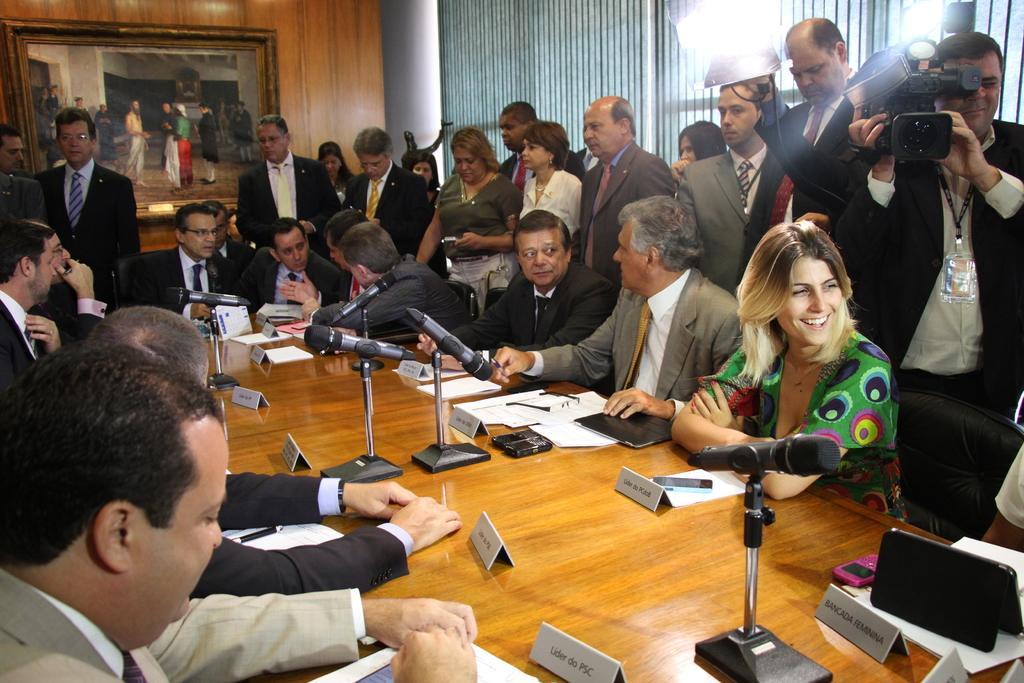Can you describe this image briefly? In this image we can see there are a group of people sitting and in front of them there are name plates, microphones, papers, electronic gadgets and a few other objects on the table, behind them there are people and one among them is holding a camera, in the background we can see the light and there is a painting on the wall. 